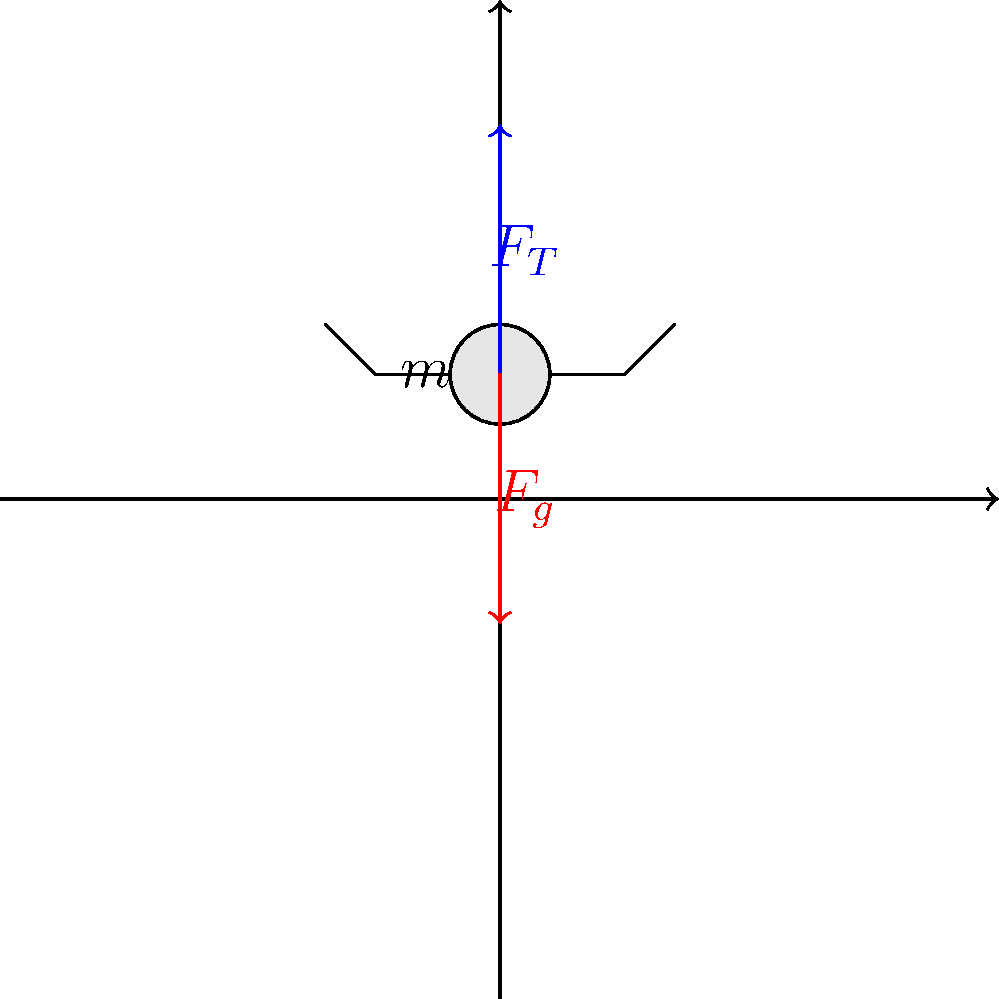A cutting-edge drone from your robotics startup is hovering steadily in midair. The drone has a mass $m$ and experiences a gravitational force $F_g$. What is the magnitude of the thrust force $F_T$ required for the drone to maintain its position, in terms of $m$ and $g$ (acceleration due to gravity)? To solve this problem, we need to analyze the forces acting on the hovering drone:

1. The gravitational force $F_g$ acts downward on the drone.
2. The thrust force $F_T$ generated by the drone's propellers acts upward.

For the drone to hover in a steady position:

1. The net force on the drone must be zero.
2. The upward and downward forces must be equal in magnitude.

We know that:
- The gravitational force is given by $F_g = mg$, where $m$ is the mass of the drone and $g$ is the acceleration due to gravity.
- For the drone to hover, $F_T$ must exactly balance $F_g$.

Therefore:

$$F_T = F_g = mg$$

This equation shows that the thrust force required to keep the drone hovering is equal to the drone's weight.
Answer: $F_T = mg$ 